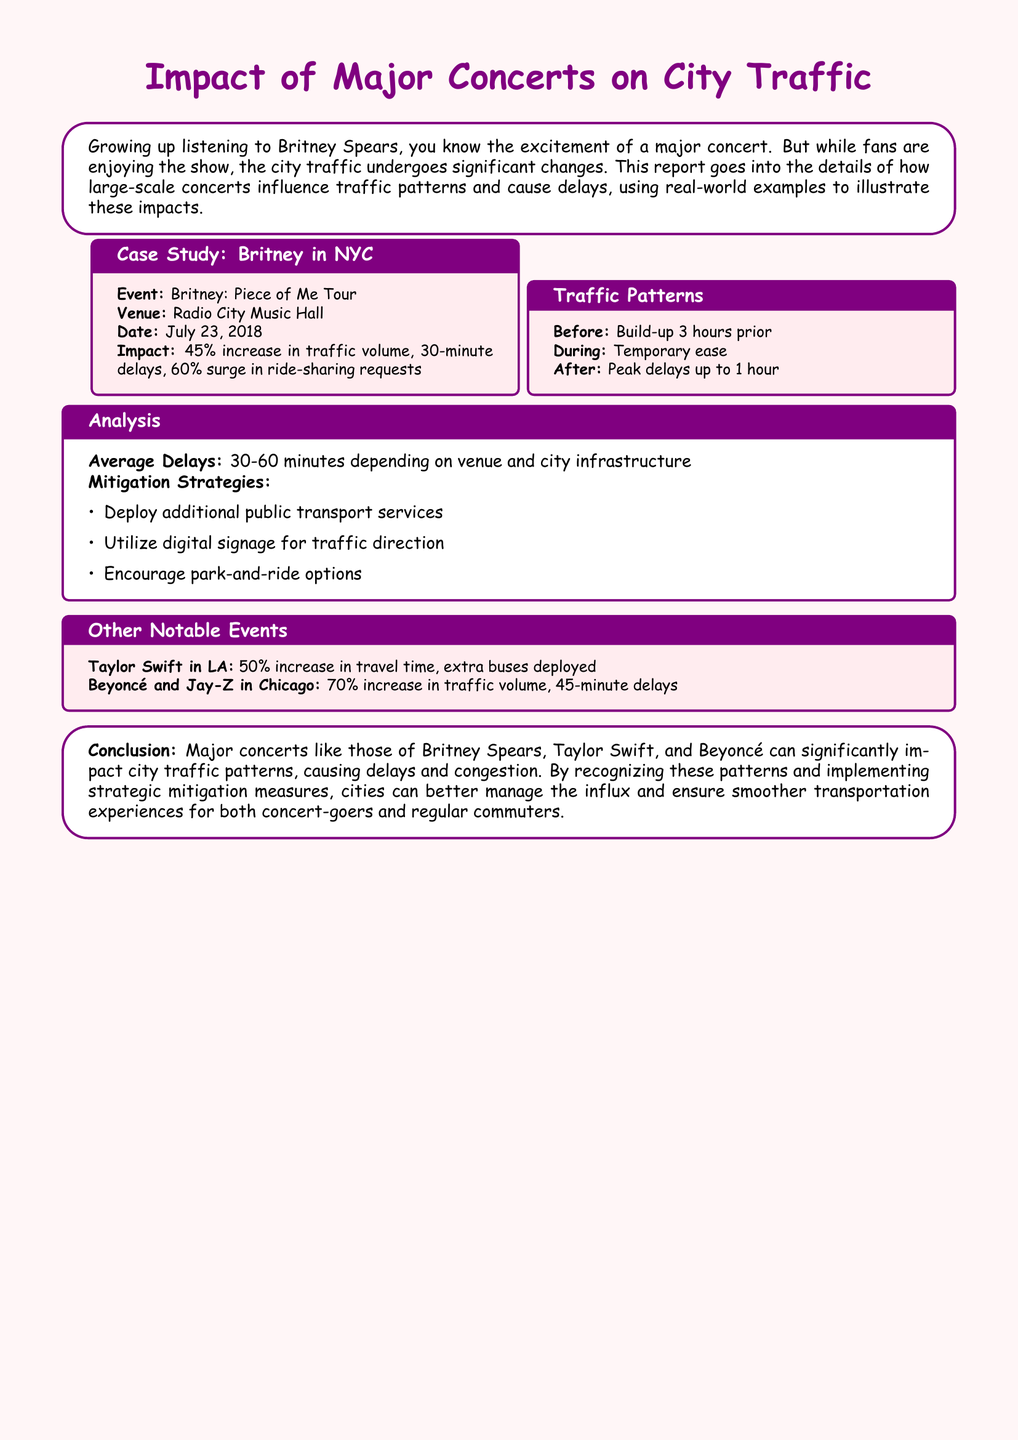what was the date of Britney's concert in NYC? The concert took place on July 23, 2018, as mentioned in the case study section.
Answer: July 23, 2018 what percentage increase in traffic volume did the concert cause? The report states a 45% increase in traffic volume due to the concert.
Answer: 45% what was the peak delay time reported after the concert? The document indicates that peak delays can reach up to 1 hour after the event.
Answer: 1 hour what mitigation strategy involves public transport? The report lists deploying additional public transport services as a strategy to manage traffic.
Answer: Additional public transport services which notable event caused a 70% increase in traffic volume? The report mentions the Beyoncé and Jay-Z concert in Chicago causing a 70% increase in traffic volume.
Answer: Beyoncé and Jay-Z in Chicago how long before the concert does traffic begin to build up? The document states that traffic begins to build up 3 hours prior to the concert.
Answer: 3 hours what is a suggested alternative to reduce parking congestion? The report encourages the use of park-and-ride options as a means to alleviate congestion.
Answer: Park-and-ride options what was the impact of Taylor Swift's concert in LA on travel time? The document specifies that Taylor Swift's concert resulted in a 50% increase in travel time.
Answer: 50% what is the color scheme used for the report's headings? The headings are designed using britneypurple and britneypink colors, reflecting a thematic style.
Answer: britneypurple and britneypink 